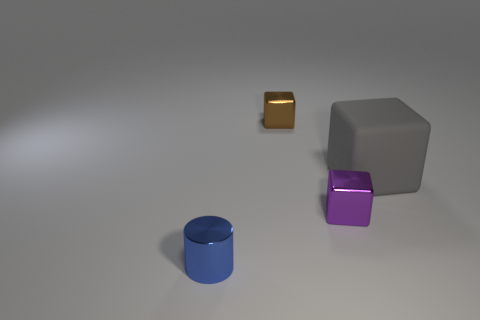Add 4 tiny blue metallic things. How many objects exist? 8 Subtract all blocks. How many objects are left? 1 Add 3 cyan spheres. How many cyan spheres exist? 3 Subtract 0 cyan cylinders. How many objects are left? 4 Subtract all red objects. Subtract all small blocks. How many objects are left? 2 Add 1 purple metallic blocks. How many purple metallic blocks are left? 2 